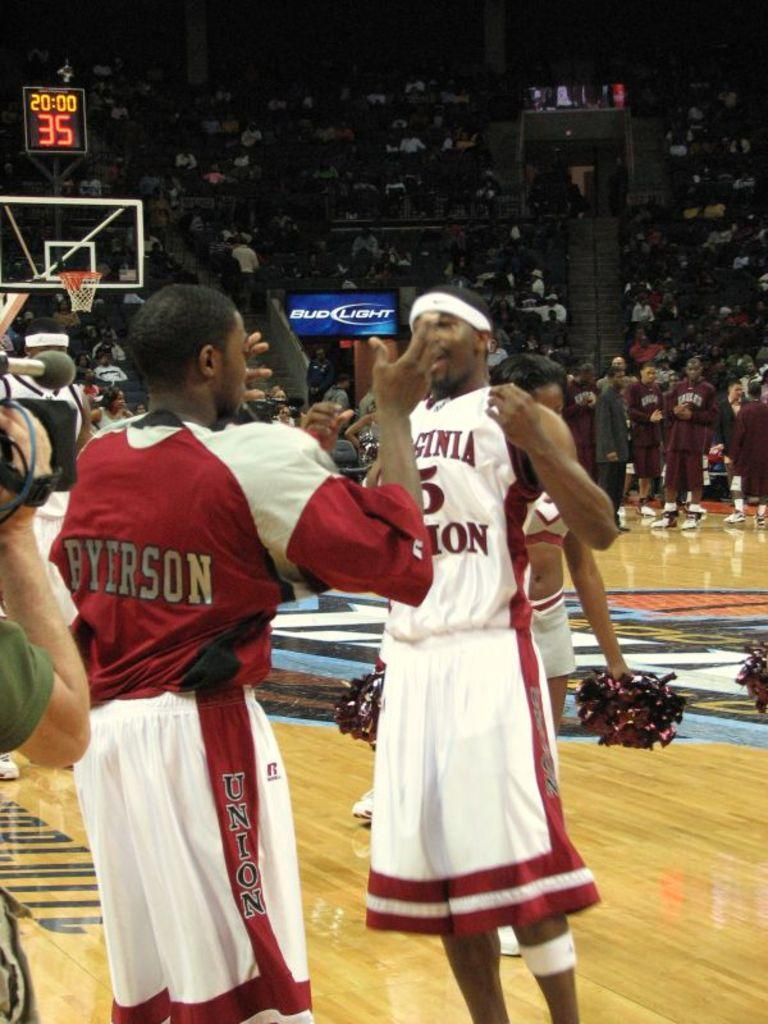<image>
Summarize the visual content of the image. the man with the back to the camera wearing a Byerson jersey 